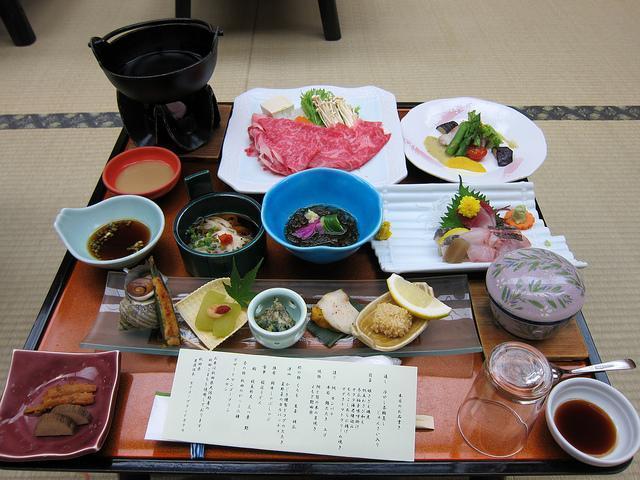Which food will add an acidic flavor to the food?
Indicate the correct response and explain using: 'Answer: answer
Rationale: rationale.'
Options: Meat, lemon, soy sauce, miso. Answer: lemon.
Rationale: The food is a lemon. 